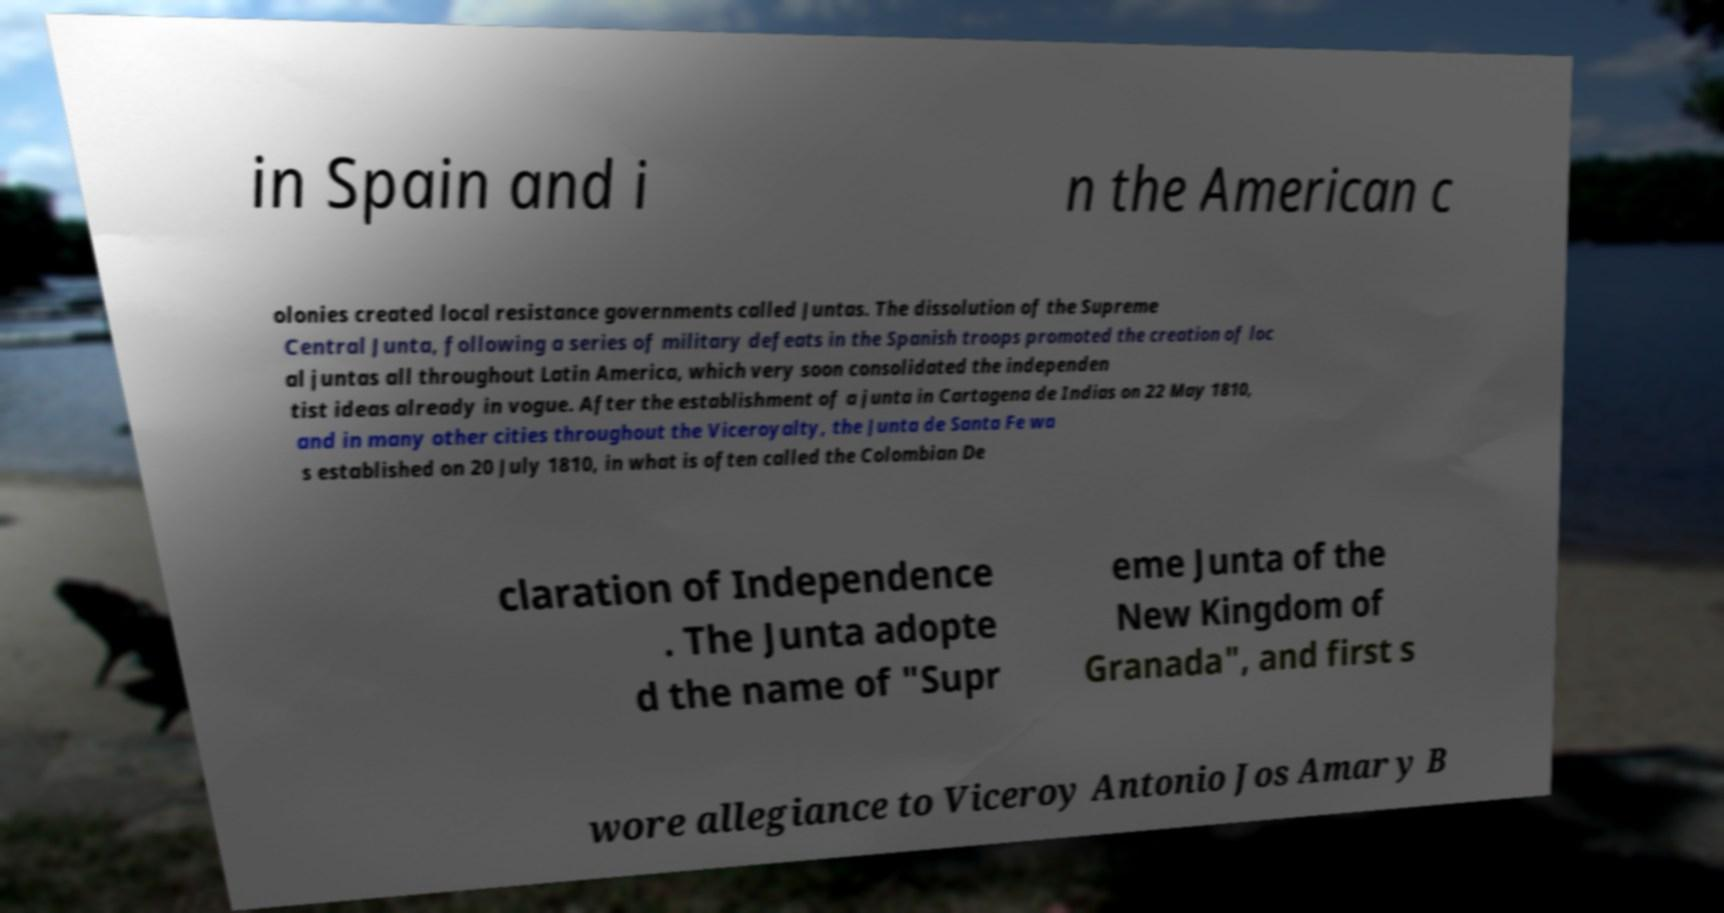Can you accurately transcribe the text from the provided image for me? in Spain and i n the American c olonies created local resistance governments called Juntas. The dissolution of the Supreme Central Junta, following a series of military defeats in the Spanish troops promoted the creation of loc al juntas all throughout Latin America, which very soon consolidated the independen tist ideas already in vogue. After the establishment of a junta in Cartagena de Indias on 22 May 1810, and in many other cities throughout the Viceroyalty, the Junta de Santa Fe wa s established on 20 July 1810, in what is often called the Colombian De claration of Independence . The Junta adopte d the name of "Supr eme Junta of the New Kingdom of Granada", and first s wore allegiance to Viceroy Antonio Jos Amar y B 